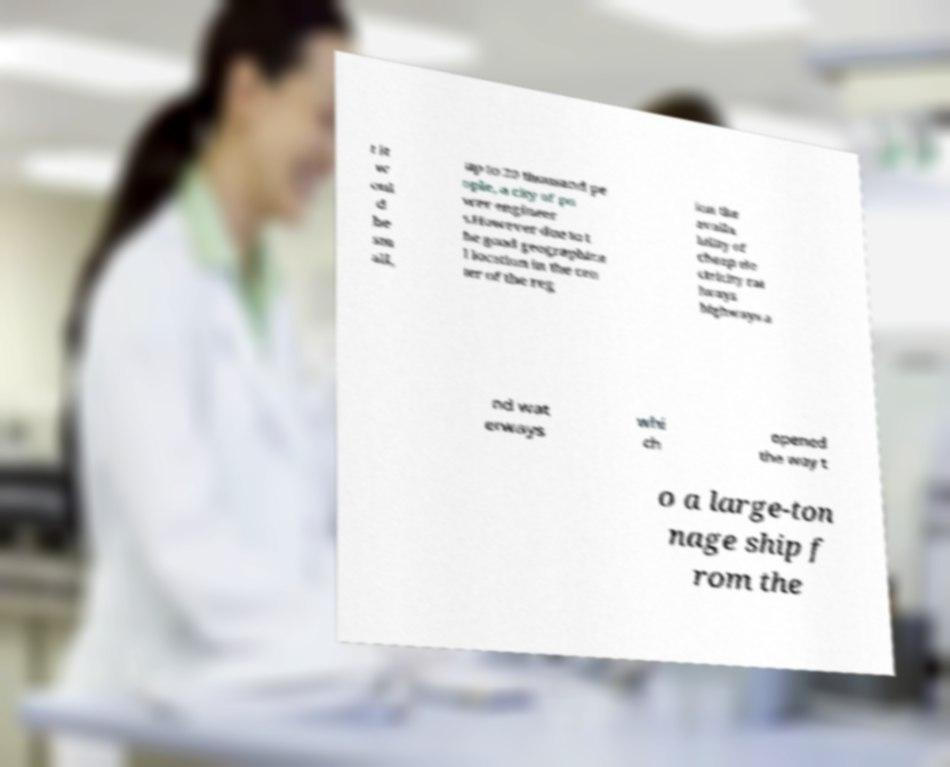Could you assist in decoding the text presented in this image and type it out clearly? t it w oul d be sm all, up to 20 thousand pe ople, a city of po wer engineer s.However due to t he good geographica l location in the cen ter of the reg ion the availa bility of cheap ele ctricity rai lways highways a nd wat erways whi ch opened the way t o a large-ton nage ship f rom the 